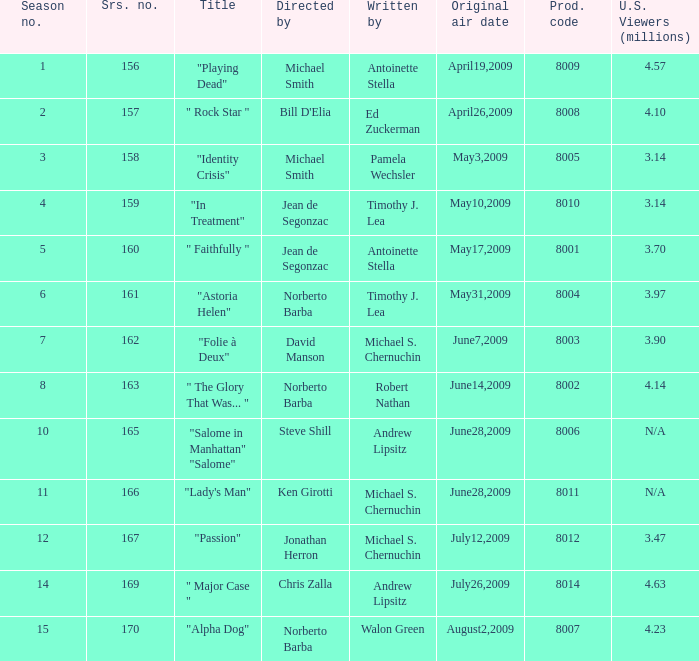How many writers write the episode whose director is Jonathan Herron? 1.0. 